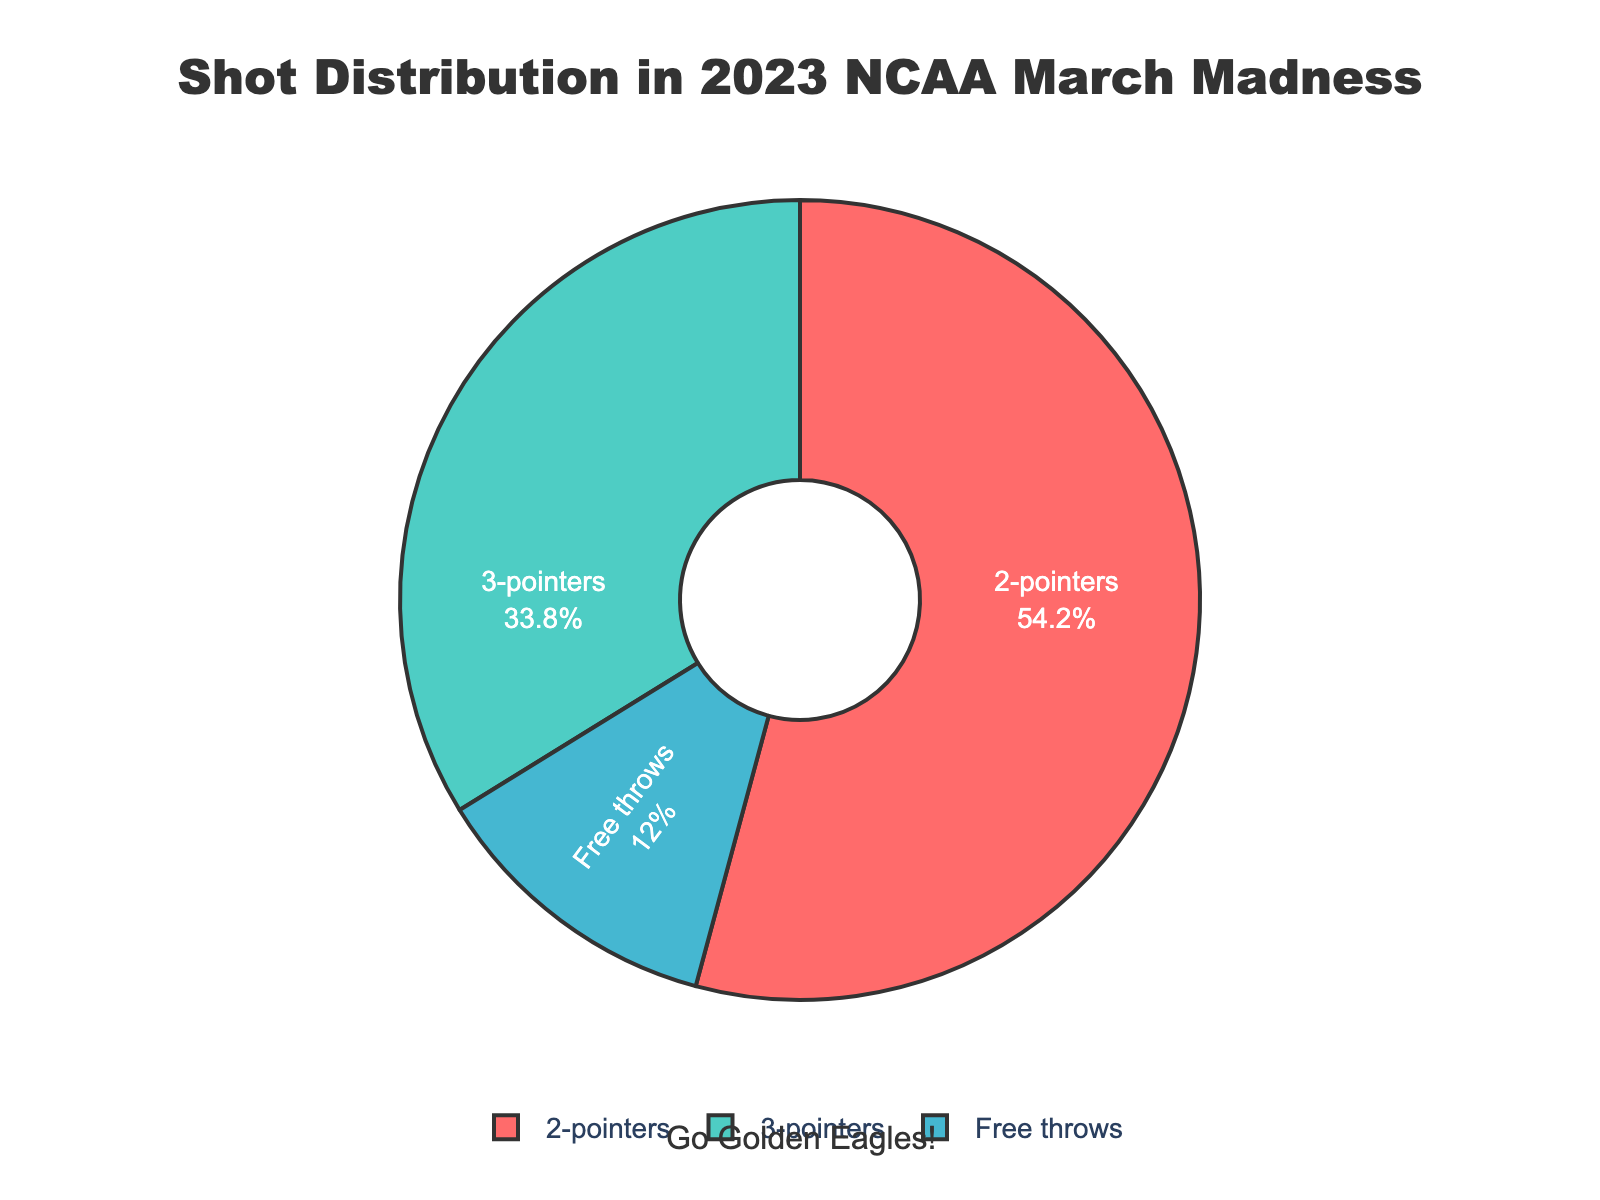What is the percentage of 2-pointers? The pie chart clearly labels each shot type with its corresponding percentage. The 2-pointers section is labeled with 54.2%.
Answer: 54.2% Which shot type has the smallest percentage? By examining the pie chart, we see that Free Throws occupy the smallest portion of the chart, labeled with 12.0%.
Answer: Free throws How much greater is the percentage of 2-pointers compared to free throws? The percentage of 2-pointers is 54.2% and free throws is 12.0%. Calculating the difference, 54.2% - 12.0% = 42.2%.
Answer: 42.2% What is the combined percentage of 2-pointers and 3-pointers? From the chart, the percentage for 2-pointers is 54.2% and for 3-pointers is 33.8%. Adding these together yields 54.2% + 33.8% = 88.0%.
Answer: 88.0% Which shot type approximately forms one-third of the total shots? Observing the pie chart, 3-pointers are labeled with 33.8%, which is close to one-third (33.33%) of the total shots.
Answer: 3-pointers Is the percentage of free throws greater than or less than 15%? Referring to the pie chart, the percentage of free throws is labeled as 12.0%, which is less than 15%.
Answer: Less than 15% How much more prevalent are 2-pointers than 3-pointers? According to the chart, the percentage for 2-pointers is 54.2% and for 3-pointers is 33.8%. The difference is 54.2% - 33.8% = 20.4%.
Answer: 20.4% What colors are used to represent each shot type? The pie chart uses distinct colors for each shot type: 2-pointers are red, 3-pointers are teal, and free throws are blue.
Answer: Red, teal, blue What is the percentage difference between the total percentages of 2-pointers and free throws combined versus the percentage of 3-pointers alone? Adding the percentages of 2-pointers (54.2%) and free throws (12.0%) gives 66.2%. The percentage of 3-pointers alone is 33.8%. The difference is 66.2% - 33.8% = 32.4%.
Answer: 32.4% If you were to divide the shot types into two groups, one with 2-pointers and the other with 3-pointers and free throws combined, which group has the higher percentage? The percentage for 2-pointers is 54.2%. The combined percentage of 3-pointers and free throws is 33.8% + 12.0% = 45.8%. Since 54.2% is greater than 45.8%, the group with only 2-pointers has the higher percentage.
Answer: 2-pointers 